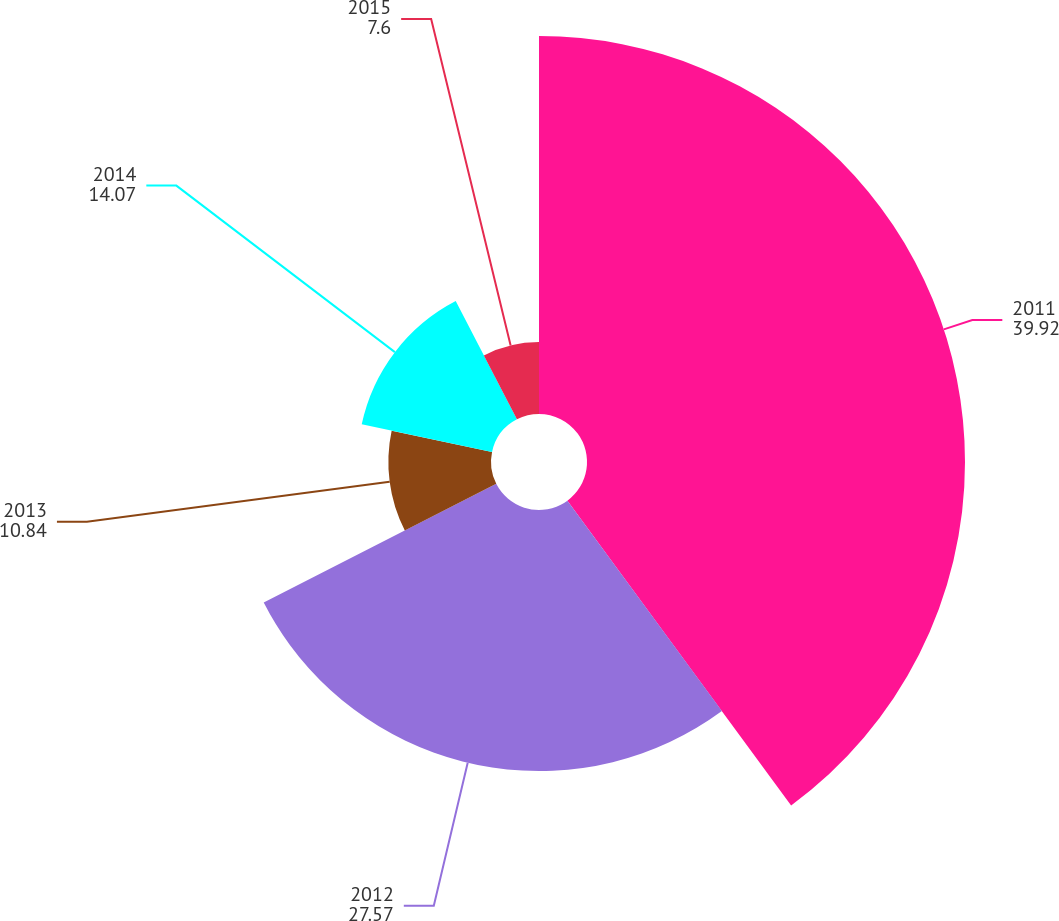<chart> <loc_0><loc_0><loc_500><loc_500><pie_chart><fcel>2011<fcel>2012<fcel>2013<fcel>2014<fcel>2015<nl><fcel>39.92%<fcel>27.57%<fcel>10.84%<fcel>14.07%<fcel>7.6%<nl></chart> 